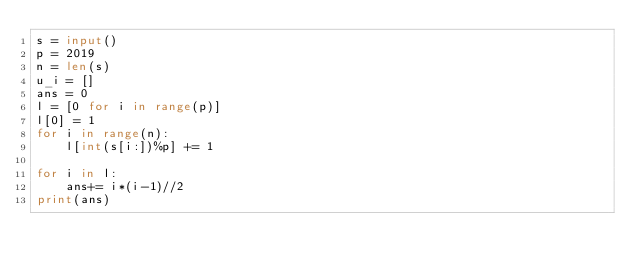Convert code to text. <code><loc_0><loc_0><loc_500><loc_500><_Python_>s = input()
p = 2019
n = len(s)
u_i = []
ans = 0
l = [0 for i in range(p)]
l[0] = 1
for i in range(n):
    l[int(s[i:])%p] += 1

for i in l:
    ans+= i*(i-1)//2
print(ans)</code> 